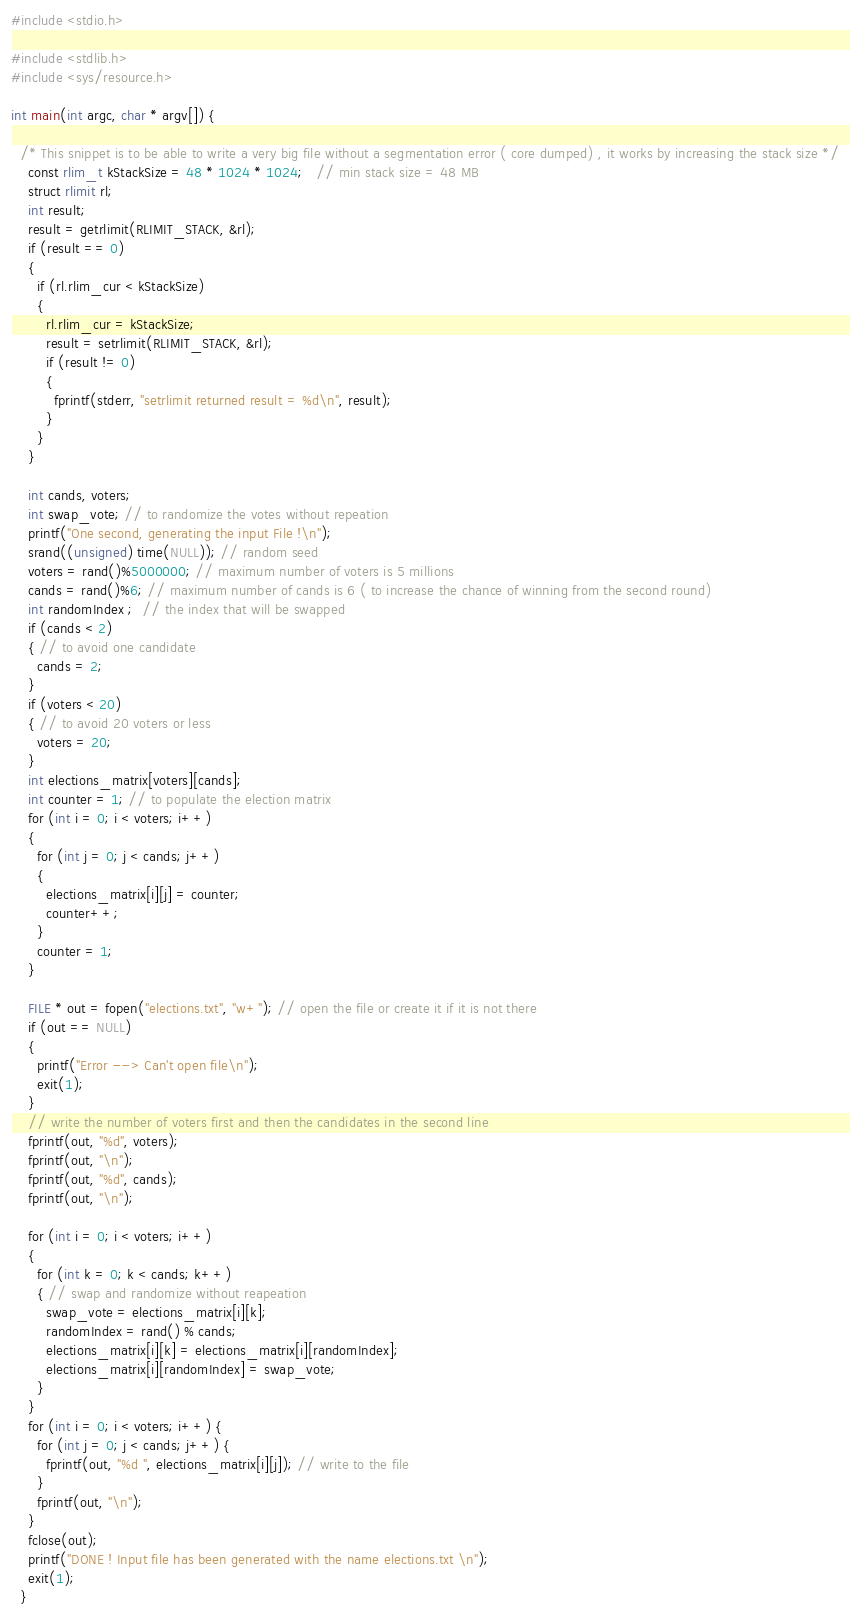<code> <loc_0><loc_0><loc_500><loc_500><_C_>#include <stdio.h>

#include <stdlib.h>
#include <sys/resource.h>

int main(int argc, char * argv[]) {

  /* This snippet is to be able to write a very big file without a segmentation error ( core dumped) , it works by increasing the stack size */
    const rlim_t kStackSize = 48 * 1024 * 1024;   // min stack size = 48 MB
    struct rlimit rl;
    int result;
    result = getrlimit(RLIMIT_STACK, &rl);
    if (result == 0)
    {
      if (rl.rlim_cur < kStackSize)
      {
        rl.rlim_cur = kStackSize;
        result = setrlimit(RLIMIT_STACK, &rl);
        if (result != 0)
        {
          fprintf(stderr, "setrlimit returned result = %d\n", result);
        }
      }
    }

    int cands, voters;
    int swap_vote; // to randomize the votes without repeation
    printf("One second, generating the input File !\n");
    srand((unsigned) time(NULL)); // random seed
    voters = rand()%5000000; // maximum number of voters is 5 millions
    cands = rand()%6; // maximum number of cands is 6 ( to increase the chance of winning from the second round)
    int randomIndex ;  // the index that will be swapped
    if (cands < 2) 
    { // to avoid one candidate
      cands = 2;
    }
    if (voters < 20) 
    { // to avoid 20 voters or less
      voters = 20;
    }
    int elections_matrix[voters][cands];
    int counter = 1; // to populate the election matrix
    for (int i = 0; i < voters; i++) 
    {
      for (int j = 0; j < cands; j++) 
      {
        elections_matrix[i][j] = counter;
        counter++;
      }
      counter = 1;
    }

    FILE * out = fopen("elections.txt", "w+"); // open the file or create it if it is not there
    if (out == NULL) 
    {
      printf("Error --> Can't open file\n");
      exit(1);
    }
    // write the number of voters first and then the candidates in the second line
    fprintf(out, "%d", voters);
    fprintf(out, "\n");
    fprintf(out, "%d", cands);
    fprintf(out, "\n");

    for (int i = 0; i < voters; i++) 
    {
      for (int k = 0; k < cands; k++) 
      { // swap and randomize without reapeation
        swap_vote = elections_matrix[i][k]; 
        randomIndex = rand() % cands;
        elections_matrix[i][k] = elections_matrix[i][randomIndex];
        elections_matrix[i][randomIndex] = swap_vote;
      }
    }
    for (int i = 0; i < voters; i++) {
      for (int j = 0; j < cands; j++) {
        fprintf(out, "%d ", elections_matrix[i][j]); // write to the file
      } 
      fprintf(out, "\n"); 
    }
    fclose(out);
    printf("DONE ! Input file has been generated with the name elections.txt \n");
    exit(1);
  }

</code> 